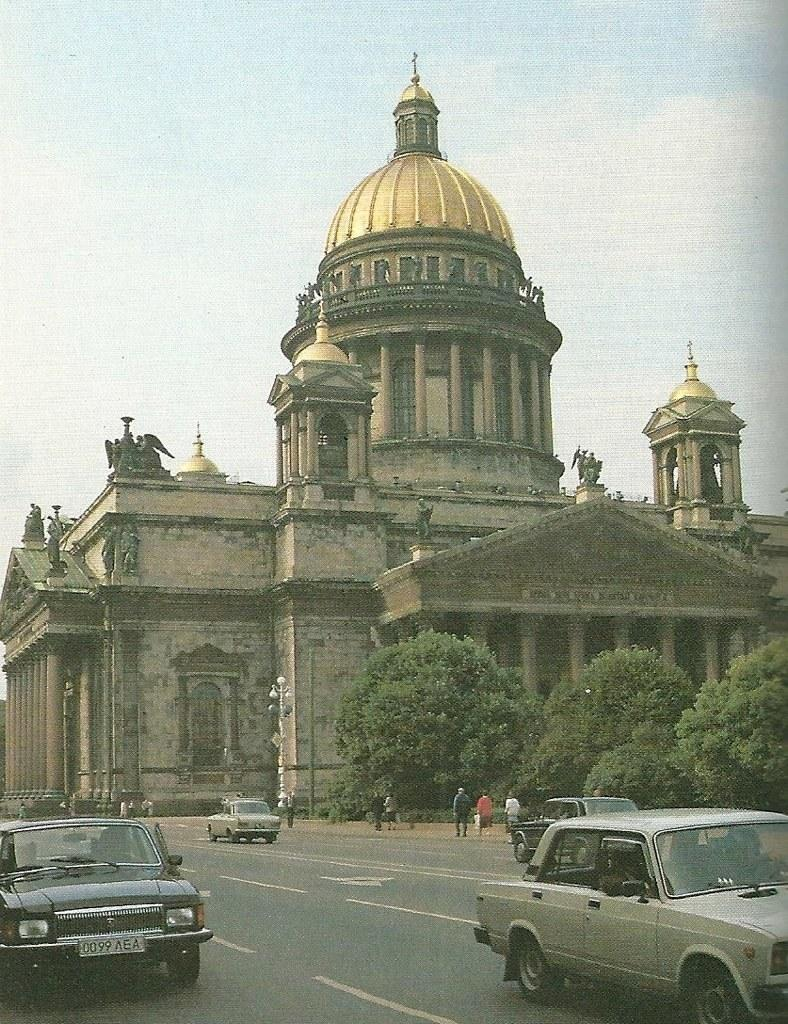What can be seen on the road in the image? There are vehicles on the road in the image. Can you describe what is happening in the distance? People are visible in the distance in the image. What type of natural elements can be seen in the background? Trees are present in the background of the image. What architectural features are present on the building? There are statues on the building on the building in the image. What type of structural support can be seen in the image? Pillars are visible in the image. What is used to provide illumination in the image? Lights are present on poles in the image. What can be seen in the sky in the image? The sky is visible with clouds in the background of the image. What type of animals can be seen at the zoo in the image? There is no zoo present in the image, so it is not possible to answer that question. What smell is coming from the banana in the image? There is no banana present in the image, so it is not possible to determine its smell. 